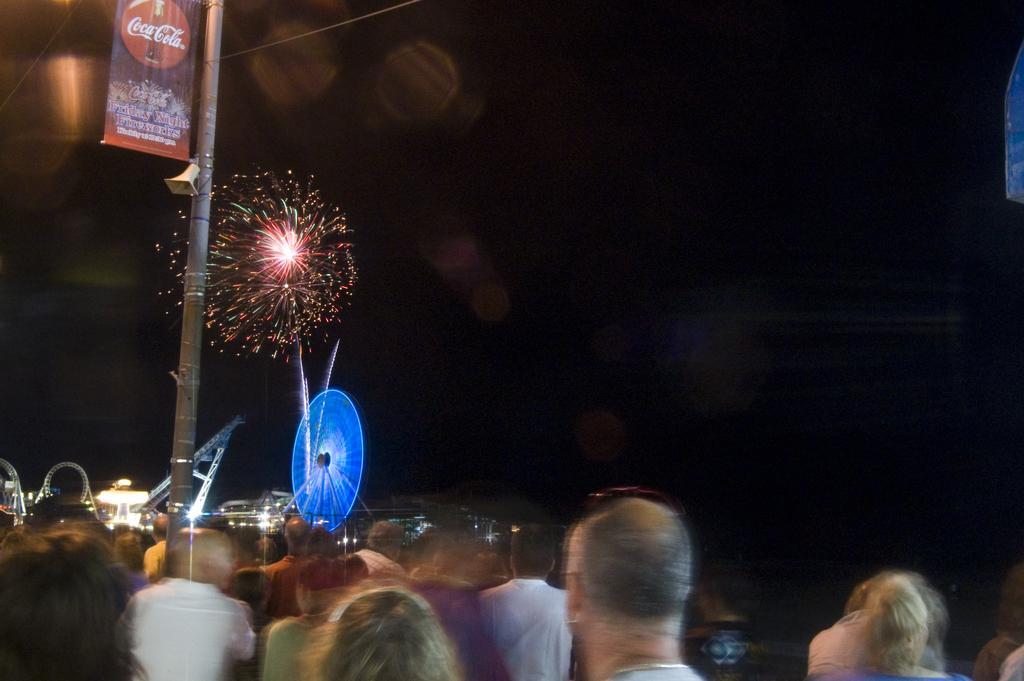What is the main subject of the image? The main subject of the image is fireworks. What else can be seen in the image besides the fireworks? There is a pole, people standing, a banner attached to the pole, and lights visible in the image. What might the pole be used for in the image? The pole might be used to support the banner or as a part of a structure for the event. How can the presence of lights be described in the image? The lights are visible in the image, possibly providing illumination or decoration. What song is being sung by the fireworks in the image? Fireworks do not sing songs; they are a visual display of light and color. 